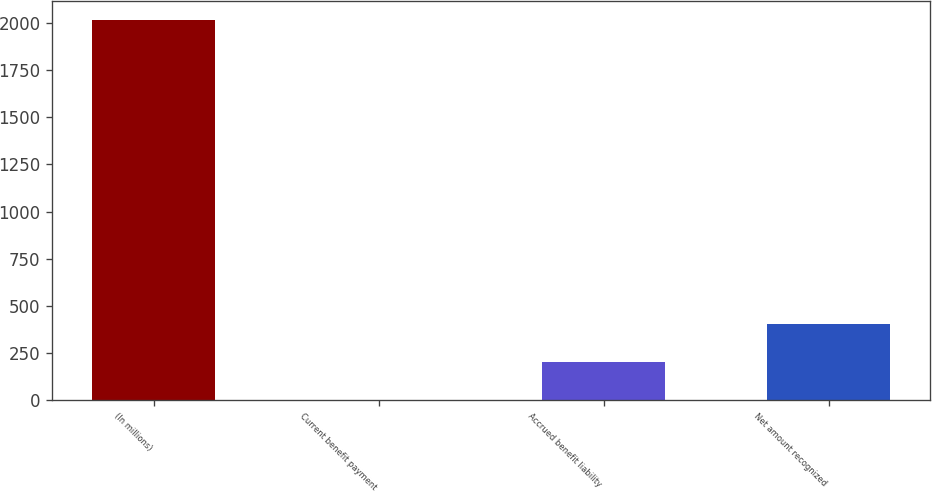<chart> <loc_0><loc_0><loc_500><loc_500><bar_chart><fcel>(In millions)<fcel>Current benefit payment<fcel>Accrued benefit liability<fcel>Net amount recognized<nl><fcel>2016<fcel>0.4<fcel>201.96<fcel>403.52<nl></chart> 